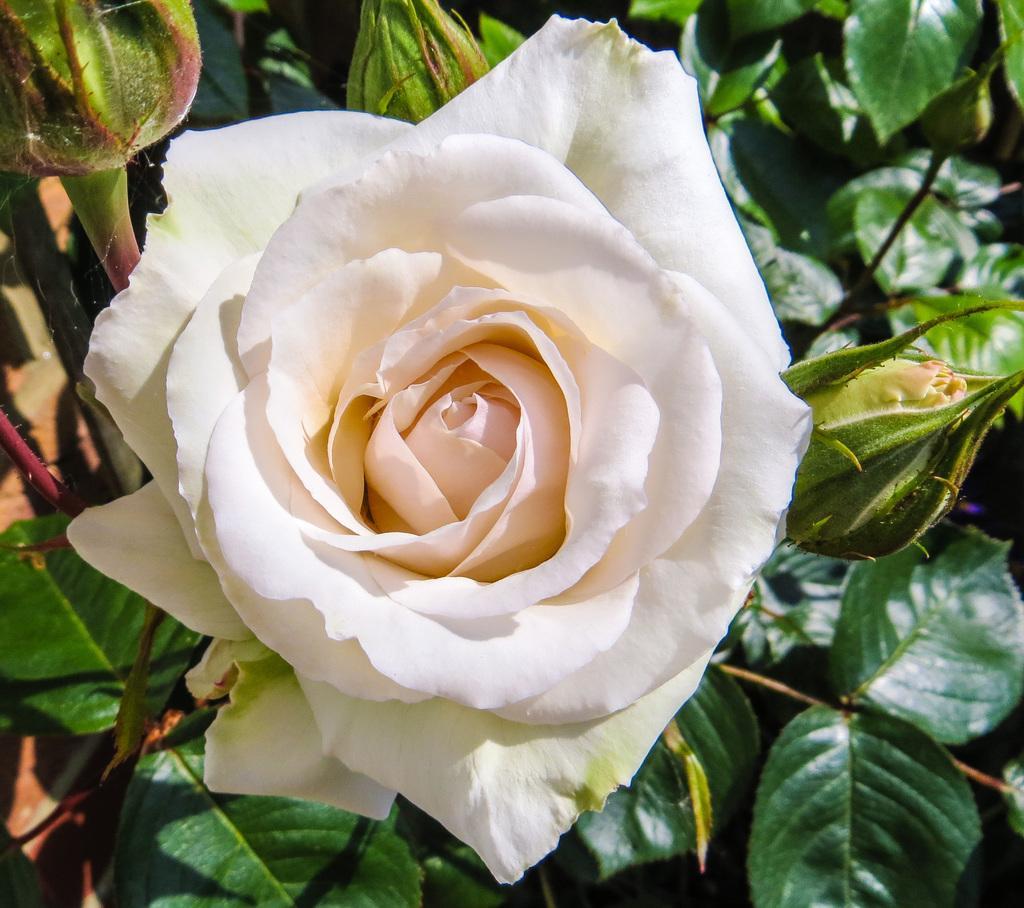Can you describe this image briefly? In this image, I can see a rose flower, which is white in color. I think these are the flower buds. I can see the leaves, which are green in color. 